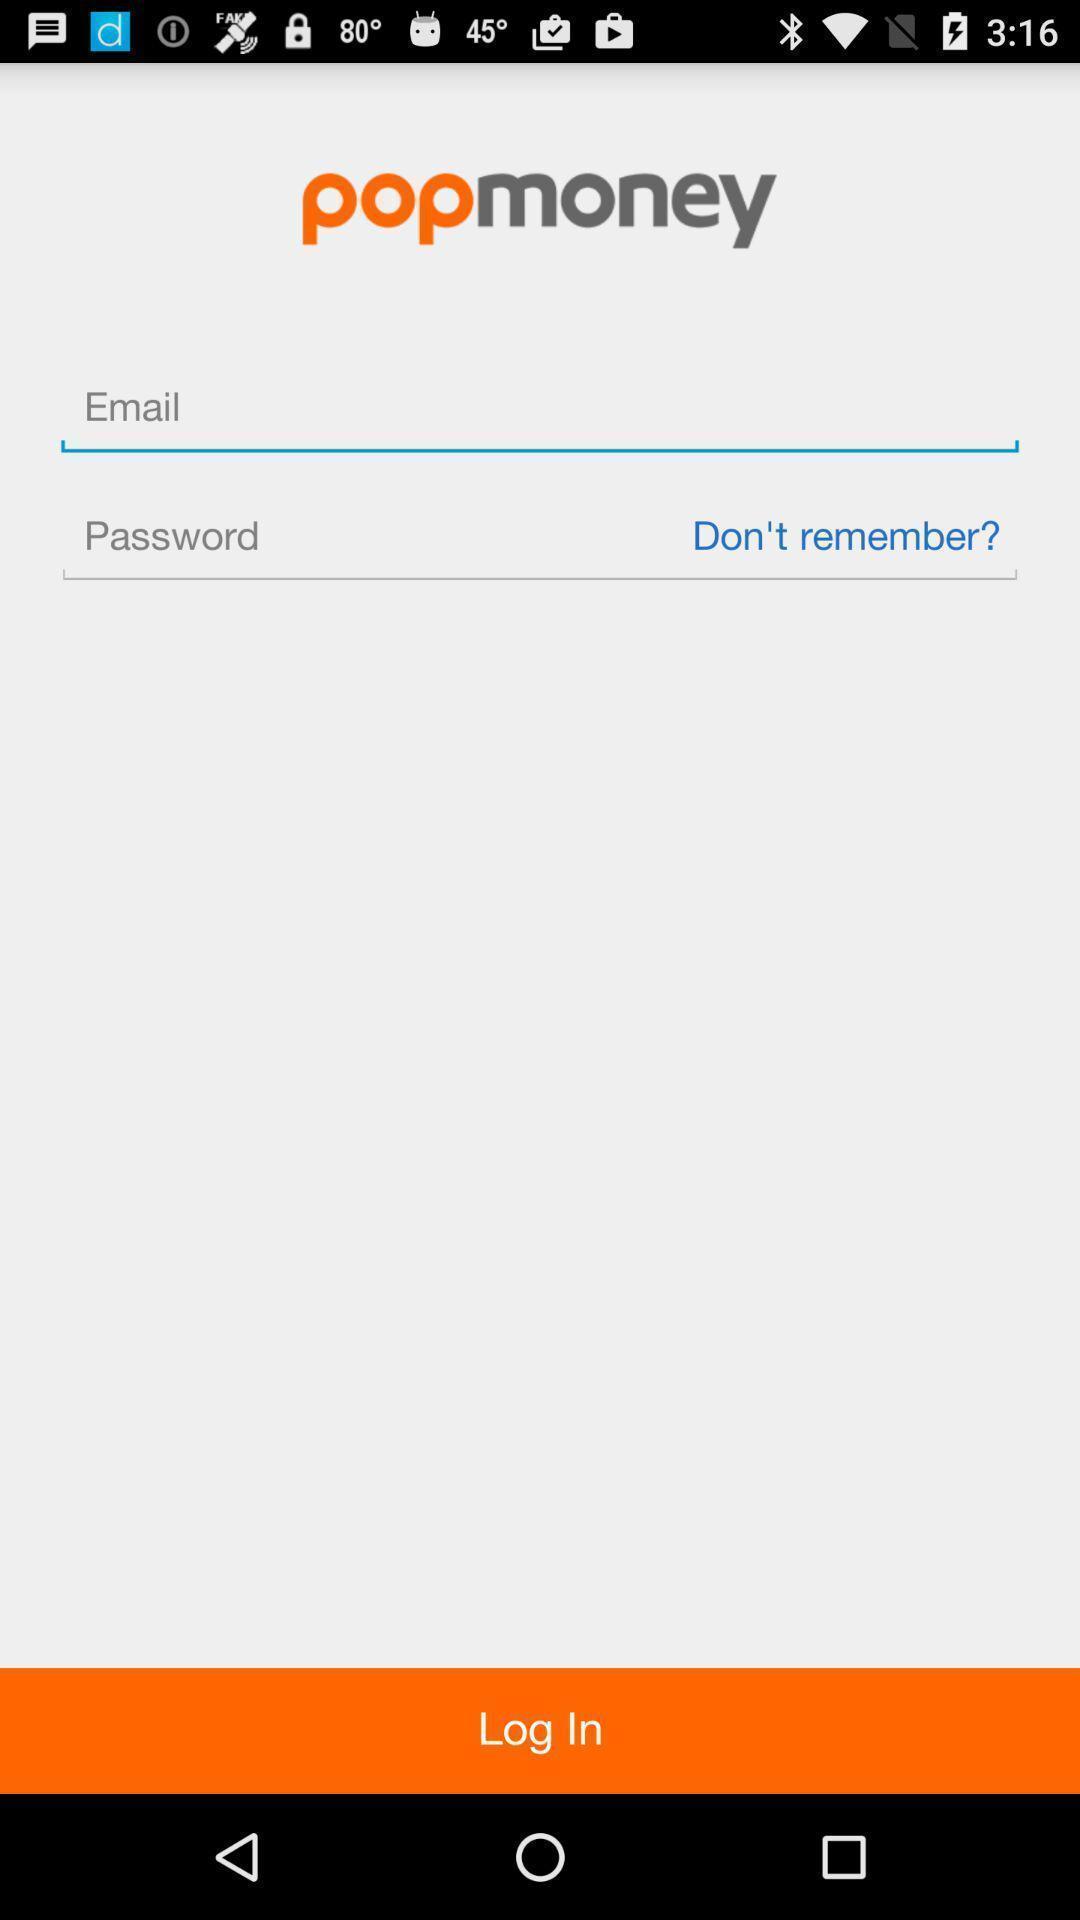Explain what's happening in this screen capture. Screen displaying contents in login page of a finance application. 